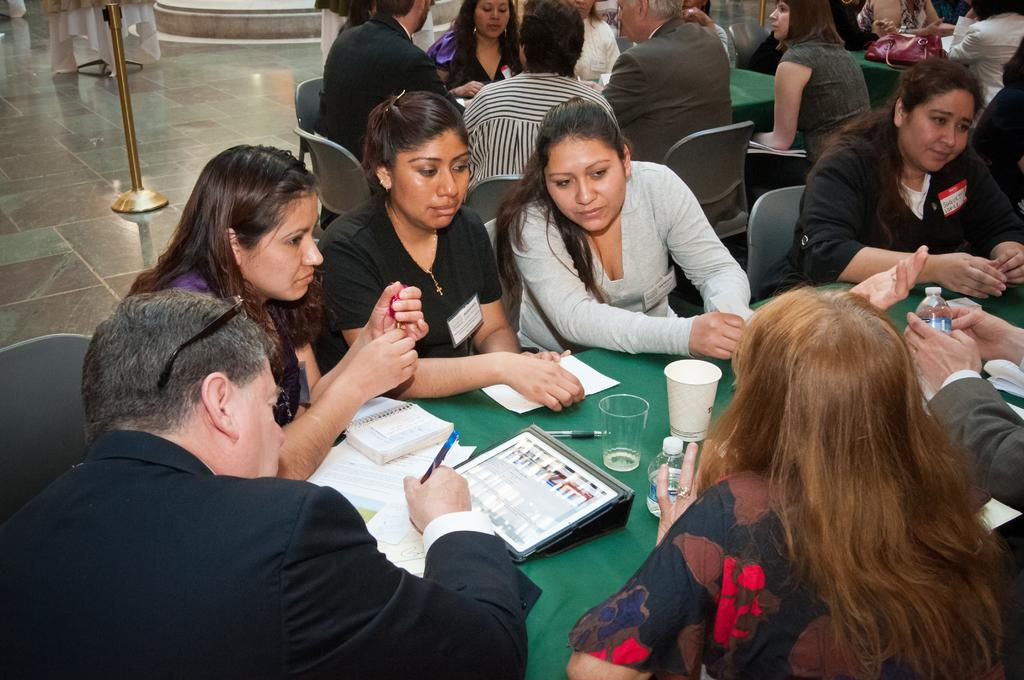What can be seen in the foreground of the picture? In the foreground of the picture, there are people, chairs, tables, glasses, papers, books, pens, bottles, and other objects. What might the people in the picture be using? The people in the picture might be using the chairs, tables, glasses, papers, books, pens, and bottles. What is located on the left side of the picture? There is a stand on the left side of the picture. How many sisters are present in the picture? There is no mention of sisters in the provided facts, so we cannot determine the number of sisters in the picture. What type of wax is being used by the people in the picture? There is no mention of wax or any wax-related activity in the provided facts, so we cannot determine if wax is being used in the picture. 